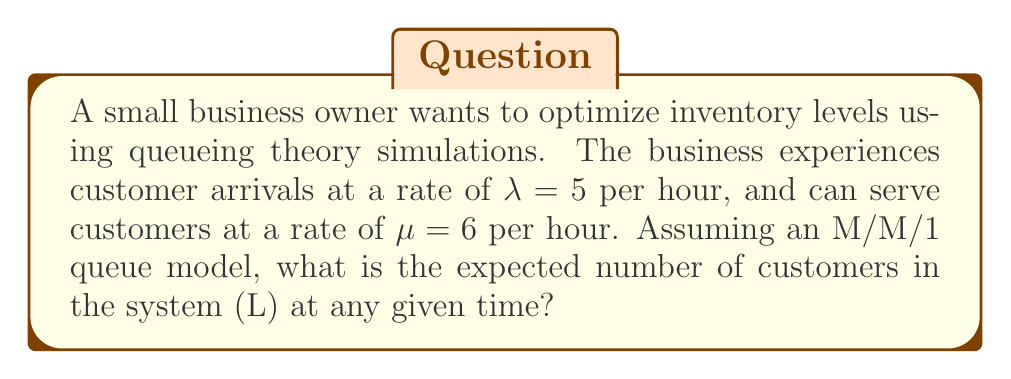Can you solve this math problem? To solve this problem, we'll use the M/M/1 queueing model, which is appropriate for a single-server system with Poisson arrivals and exponential service times. The steps to find the expected number of customers in the system (L) are as follows:

1. Define the variables:
   $\lambda$ = arrival rate = 5 customers/hour
   $\mu$ = service rate = 6 customers/hour

2. Calculate the utilization factor $\rho$:
   $$\rho = \frac{\lambda}{\mu} = \frac{5}{6} \approx 0.833$$

3. Use the formula for the expected number of customers in the system (L) for an M/M/1 queue:
   $$L = \frac{\rho}{1 - \rho}$$

4. Substitute the calculated $\rho$ value:
   $$L = \frac{0.833}{1 - 0.833} = \frac{0.833}{0.167} \approx 4.988$$

5. Round to two decimal places for a practical answer:
   $$L \approx 4.99$$

This result means that, on average, there will be approximately 5 customers in the system (either being served or waiting) at any given time.
Answer: 4.99 customers 